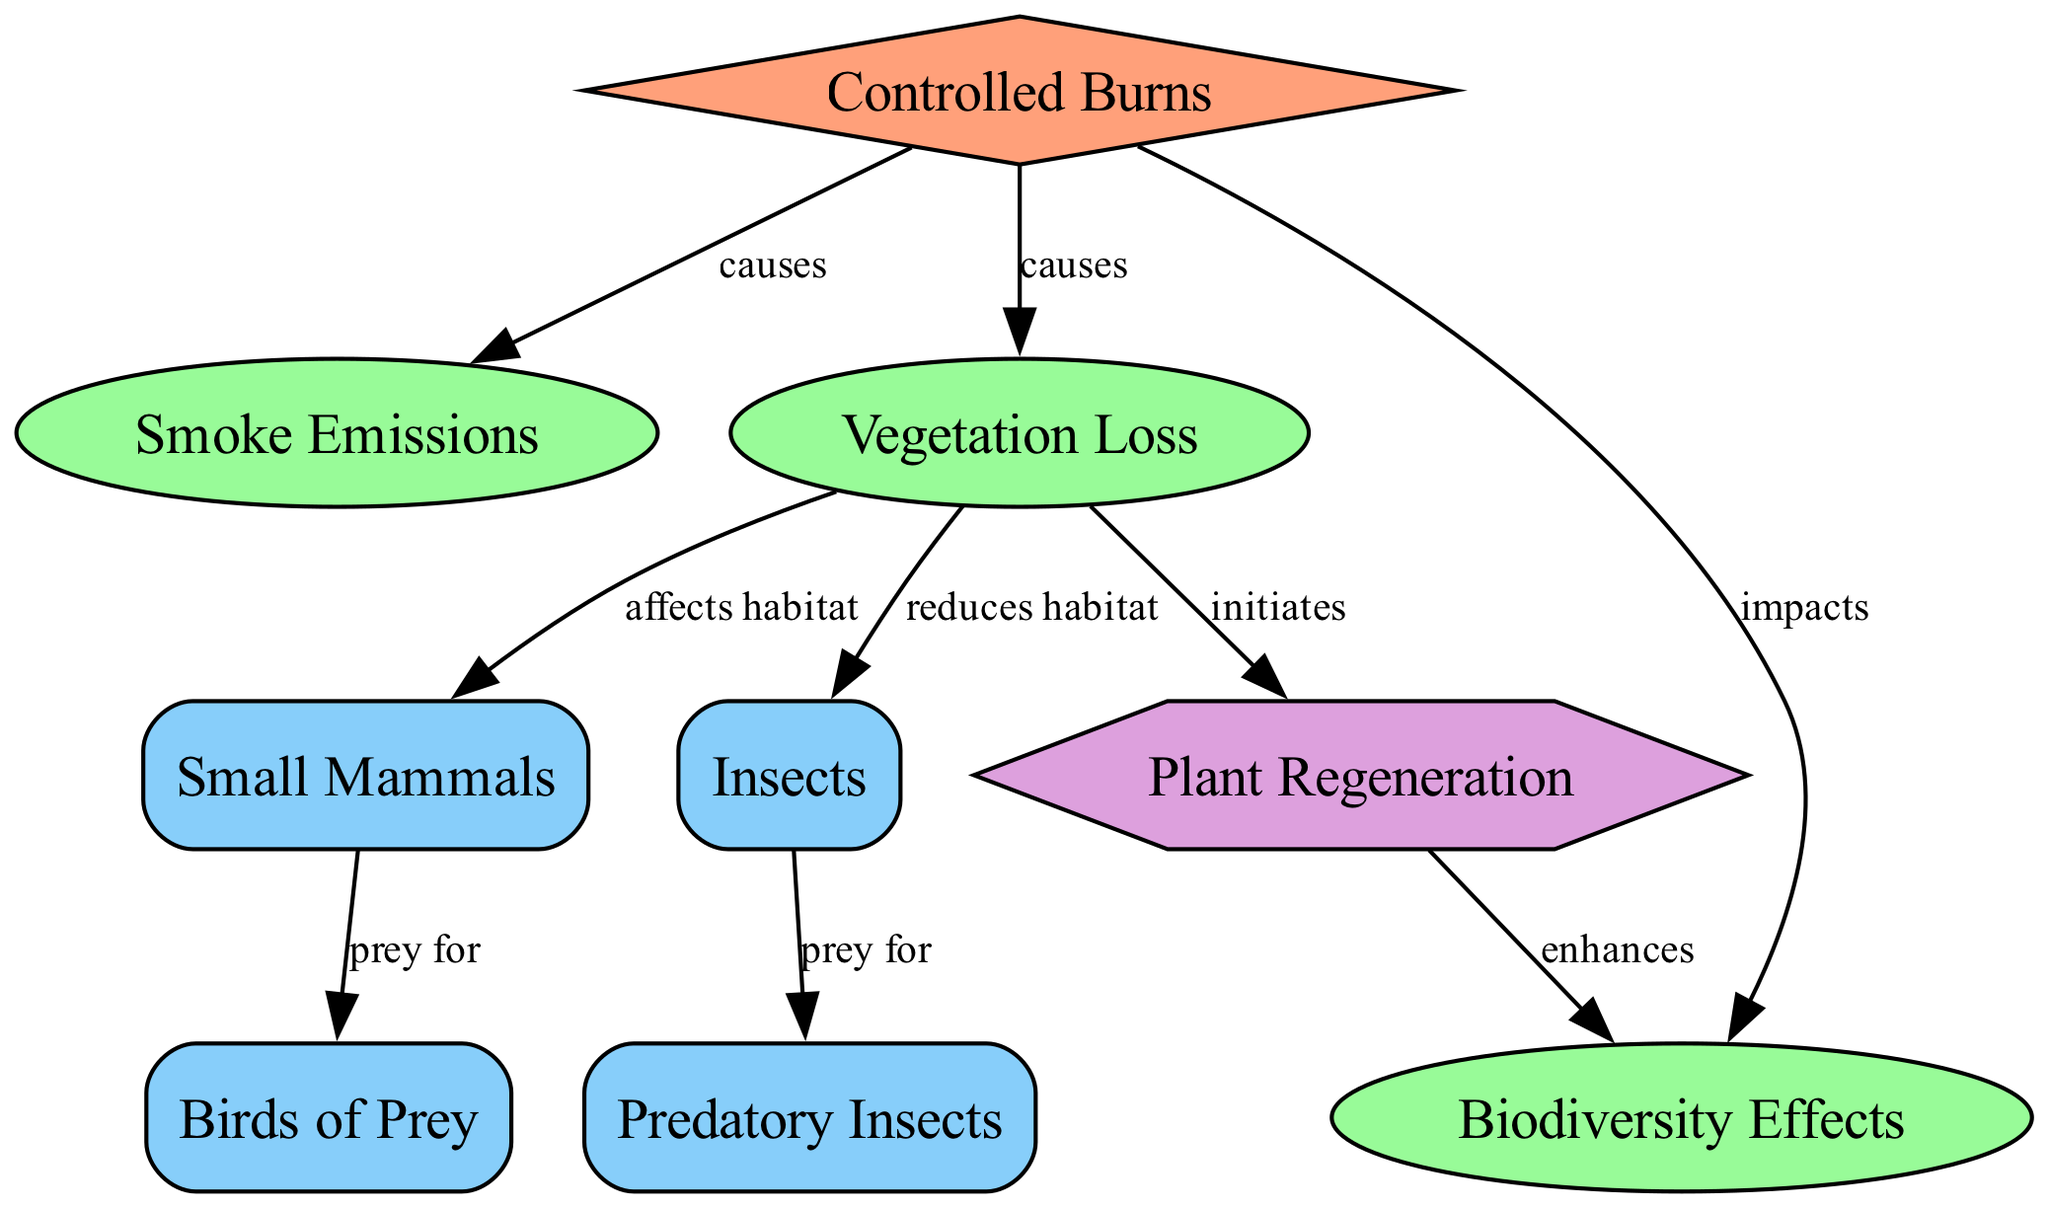What event causes smoke emissions? The diagram shows that "Controlled Burns" is the event that has a direct edge indicating it "causes" "Smoke Emissions".
Answer: Controlled Burns How many wildlife nodes are present in the diagram? In the diagram, there are four wildlife nodes: "Small Mammals", "Insects", "Birds of Prey", and "Predatory Insects". Therefore, the total count is four.
Answer: 4 What is the effect of vegetation loss on small mammals? The diagram indicates that "Vegetation Loss" "affects habitat" for "Small Mammals". Thus, the relationship is that it negatively impacts their habitat.
Answer: Affects habitat What do controlled burns impact directly? Looking at the edges, "Controlled Burns" directly impacts "Smoke Emissions", "Vegetation Loss", and "Biodiversity Effects". The question, however, asks for the direct impact on the effects, which would be "Biodiversity Effects".
Answer: Biodiversity Effects Which type of wildlife is directly preyed on by predatory insects? According to the diagram, "Insects" are explicitly shown to be preyed on by "Predatory Insects". This indicates a direct relationship of predation.
Answer: Insects What initiates plant regeneration? The diagram states that "Vegetation Loss" "initiates" "Plant Regeneration". Hence, the cause of plant regeneration here is vegetation loss.
Answer: Vegetation Loss Which wildlife type is a prey source for birds of prey? From the diagram, it is clear that "Small Mammals" are indicated as prey for "Birds of Prey". This shows a direct relationship of prey and predator.
Answer: Small Mammals How does plant regeneration affect biodiversity? The diagram connects "Plant Regeneration" with "Biodiversity Effects" stating that it "enhances" biodiversity. Therefore, the process of plant regeneration has a positive impact on biodiversity.
Answer: Enhances What is the relationship between vegetation loss and biodiversity effects? The diagram shows that "Biodiversity Effects" are impacted by "Controlled Burns" and that "Vegetation Loss" initiates "Plant Regeneration", which then enhances biodiversity effects. In summary, vegetation loss indirectly affects biodiversity through plant regeneration.
Answer: Indirectly affects 